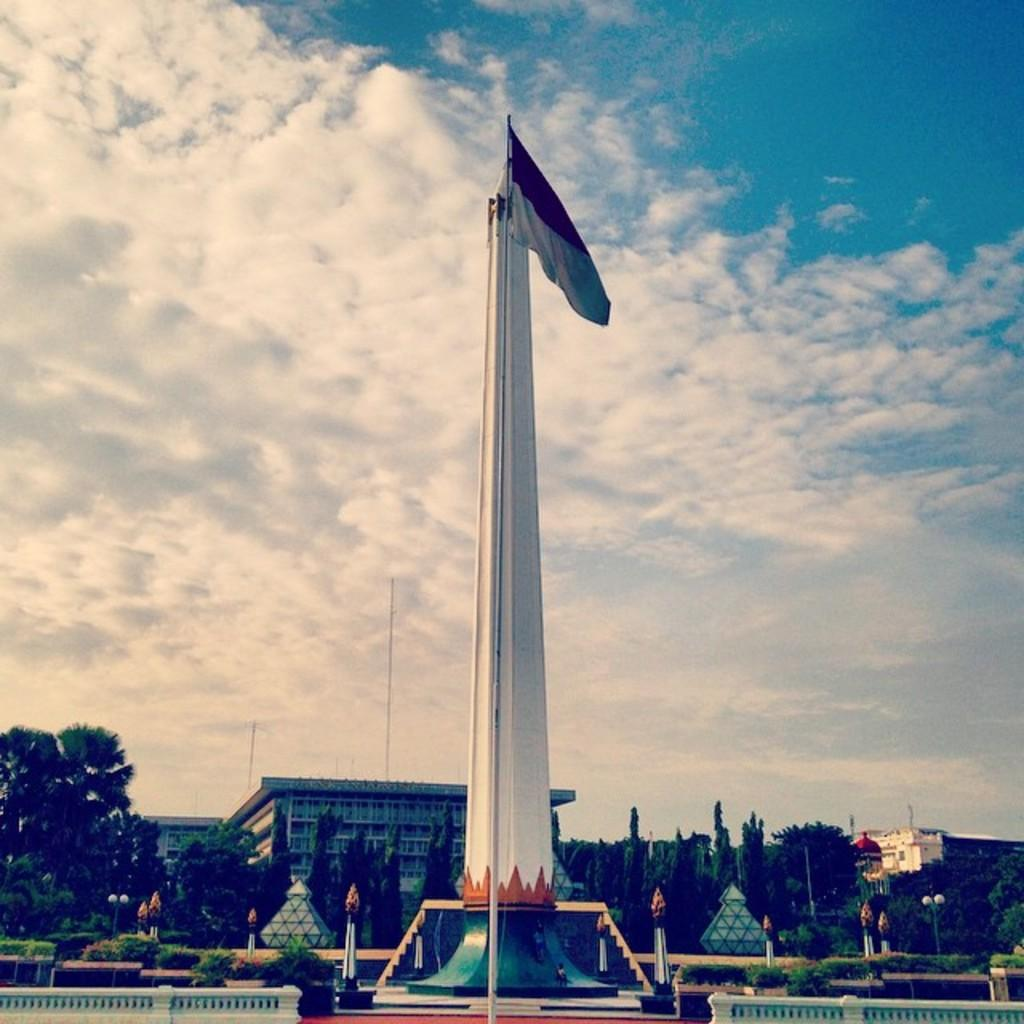What is located in the middle of the image? There is a pillar and a flag in the middle of the image. What type of vegetation can be seen in the image? There are trees visible in the image. What type of structure is present in the image? There is a building in the image. What is visible at the top of the image? The sky is visible at the top of the image. What type of arch can be seen in the image? There is no arch present in the image. Is the carpenter working on the building in the image? There is no carpenter or indication of any construction work in the image. Can you tell me the name of the aunt who is standing near the building in the image? There is no aunt or person visible in the image. 